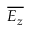<formula> <loc_0><loc_0><loc_500><loc_500>\overline { { E _ { z } } }</formula> 